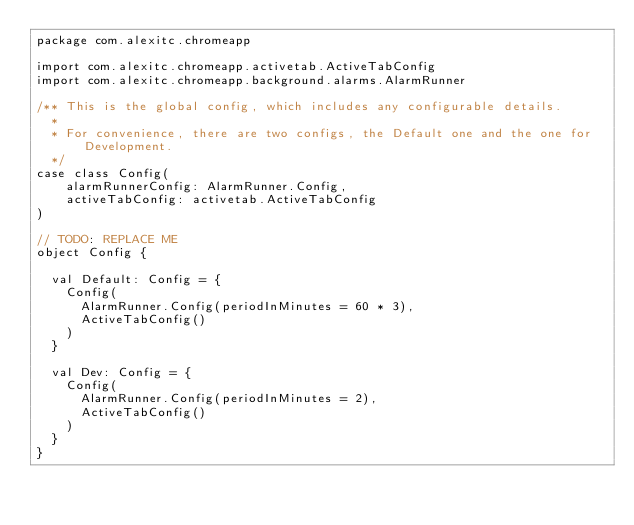Convert code to text. <code><loc_0><loc_0><loc_500><loc_500><_Scala_>package com.alexitc.chromeapp

import com.alexitc.chromeapp.activetab.ActiveTabConfig
import com.alexitc.chromeapp.background.alarms.AlarmRunner

/** This is the global config, which includes any configurable details.
  *
  * For convenience, there are two configs, the Default one and the one for Development.
  */
case class Config(
    alarmRunnerConfig: AlarmRunner.Config,
    activeTabConfig: activetab.ActiveTabConfig
)

// TODO: REPLACE ME
object Config {

  val Default: Config = {
    Config(
      AlarmRunner.Config(periodInMinutes = 60 * 3),
      ActiveTabConfig()
    )
  }

  val Dev: Config = {
    Config(
      AlarmRunner.Config(periodInMinutes = 2),
      ActiveTabConfig()
    )
  }
}
</code> 